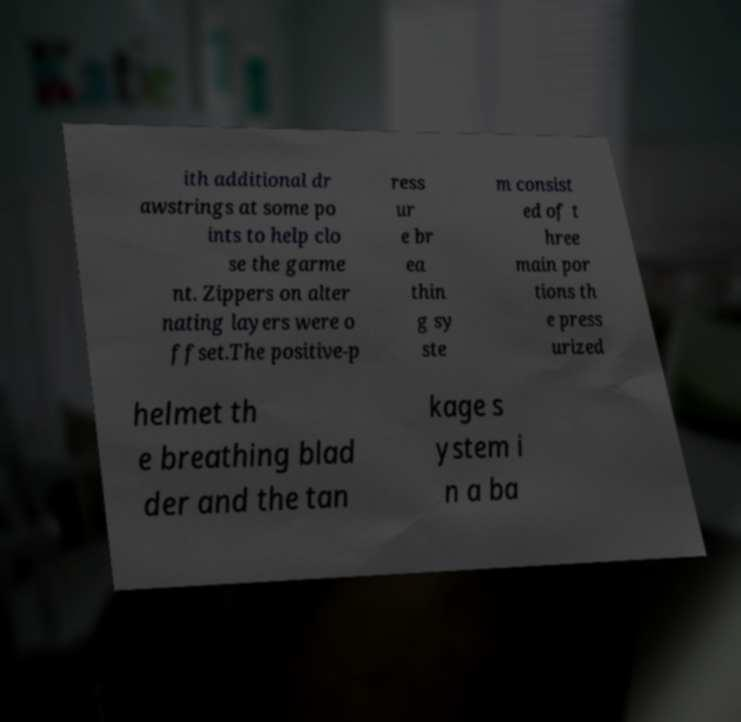Can you accurately transcribe the text from the provided image for me? ith additional dr awstrings at some po ints to help clo se the garme nt. Zippers on alter nating layers were o ffset.The positive-p ress ur e br ea thin g sy ste m consist ed of t hree main por tions th e press urized helmet th e breathing blad der and the tan kage s ystem i n a ba 